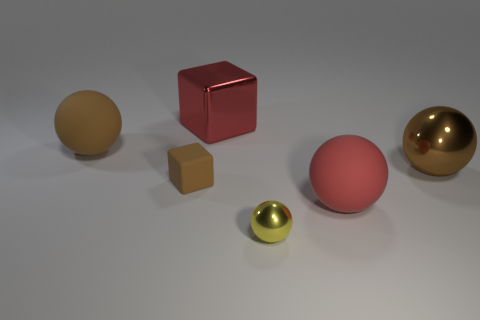Is the brown block made of the same material as the brown ball right of the yellow metallic sphere?
Your answer should be very brief. No. Do the matte object that is in front of the tiny cube and the rubber block have the same color?
Make the answer very short. No. There is a thing that is left of the big cube and behind the tiny rubber cube; what material is it?
Make the answer very short. Rubber. The yellow metallic ball is what size?
Provide a short and direct response. Small. There is a tiny rubber block; is it the same color as the large ball behind the large brown metallic sphere?
Ensure brevity in your answer.  Yes. How many other objects are the same color as the shiny cube?
Your answer should be very brief. 1. There is a red object in front of the large block; is it the same size as the shiny ball in front of the large red matte thing?
Offer a terse response. No. There is a matte sphere behind the red rubber sphere; what is its color?
Ensure brevity in your answer.  Brown. Are there fewer metal things that are behind the shiny block than red matte cylinders?
Provide a short and direct response. No. Are the yellow sphere and the big cube made of the same material?
Offer a terse response. Yes. 